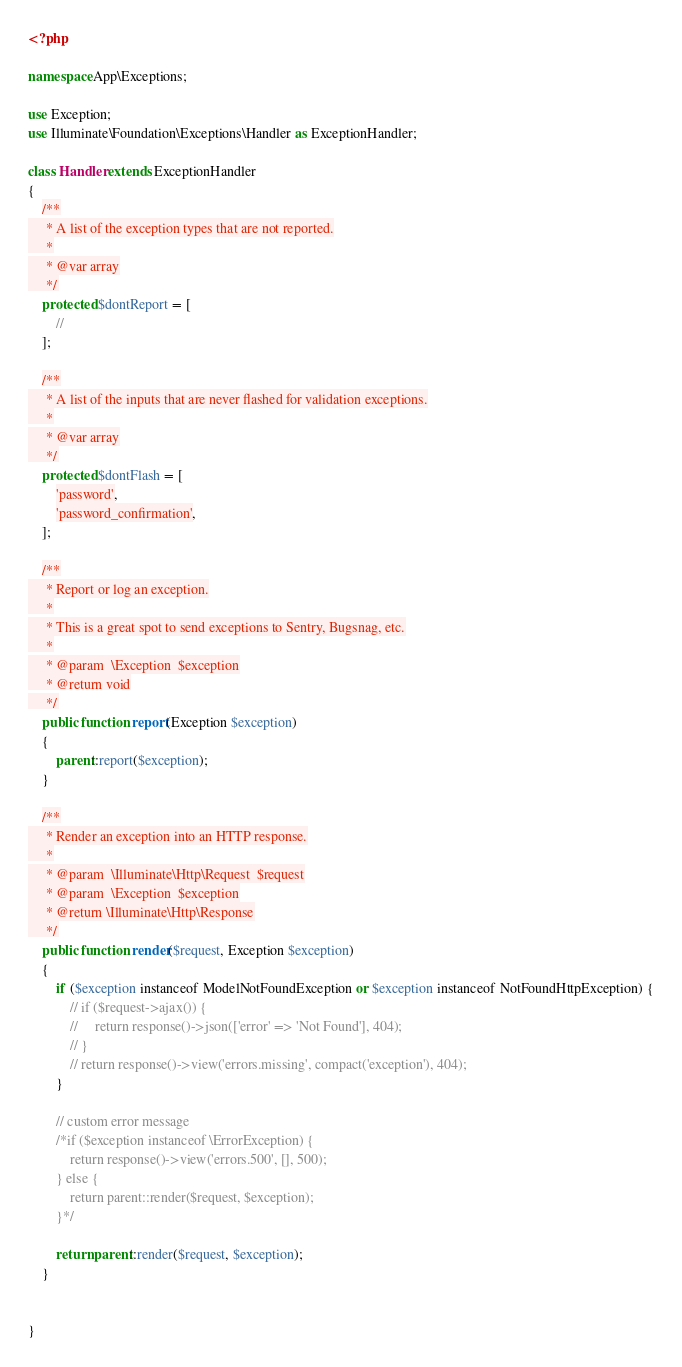<code> <loc_0><loc_0><loc_500><loc_500><_PHP_><?php

namespace App\Exceptions;

use Exception;
use Illuminate\Foundation\Exceptions\Handler as ExceptionHandler;

class Handler extends ExceptionHandler
{
    /**
     * A list of the exception types that are not reported.
     *
     * @var array
     */
    protected $dontReport = [
        //
    ];

    /**
     * A list of the inputs that are never flashed for validation exceptions.
     *
     * @var array
     */
    protected $dontFlash = [
        'password',
        'password_confirmation',
    ];

    /**
     * Report or log an exception.
     *
     * This is a great spot to send exceptions to Sentry, Bugsnag, etc.
     *
     * @param  \Exception  $exception
     * @return void
     */
    public function report(Exception $exception)
    {
        parent::report($exception);
    }

    /**
     * Render an exception into an HTTP response.
     *
     * @param  \Illuminate\Http\Request  $request
     * @param  \Exception  $exception
     * @return \Illuminate\Http\Response
     */
    public function render($request, Exception $exception)
    {
        if ($exception instanceof ModelNotFoundException or $exception instanceof NotFoundHttpException) {
            // if ($request->ajax()) {
            //     return response()->json(['error' => 'Not Found'], 404);
            // }
            // return response()->view('errors.missing', compact('exception'), 404);
        }

        // custom error message
        /*if ($exception instanceof \ErrorException) {
            return response()->view('errors.500', [], 500);
        } else {
            return parent::render($request, $exception);
        }*/
    
        return parent::render($request, $exception);
    }

    
}
</code> 